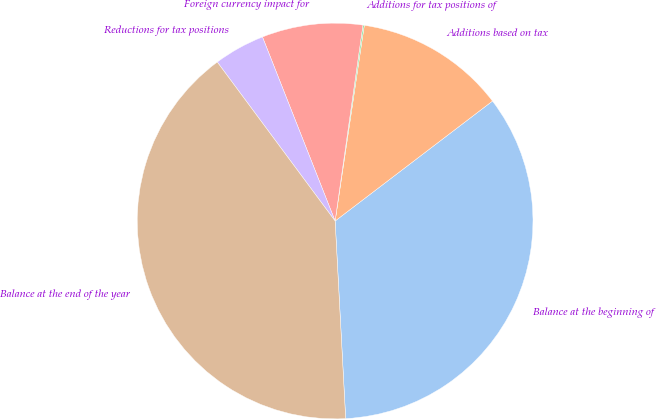Convert chart. <chart><loc_0><loc_0><loc_500><loc_500><pie_chart><fcel>Balance at the beginning of<fcel>Additions based on tax<fcel>Additions for tax positions of<fcel>Foreign currency impact for<fcel>Reductions for tax positions<fcel>Balance at the end of the year<nl><fcel>34.52%<fcel>12.28%<fcel>0.11%<fcel>8.23%<fcel>4.17%<fcel>40.7%<nl></chart> 